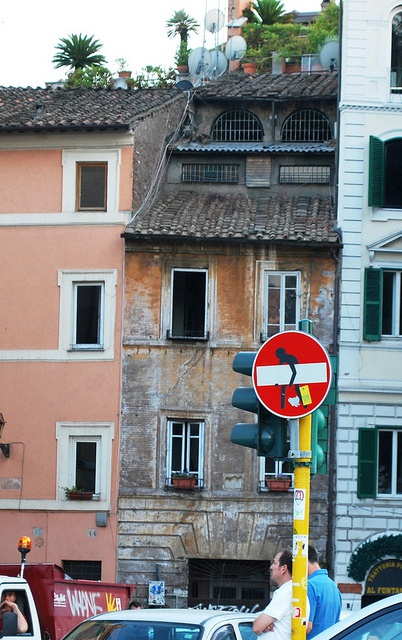Describe the objects in this image and their specific colors. I can see truck in white, maroon, brown, lightgray, and black tones, car in white, lightblue, blue, and gray tones, stop sign in white, red, lightblue, brown, and navy tones, car in white, lightblue, gray, and blue tones, and people in white, lightpink, darkgray, and gray tones in this image. 